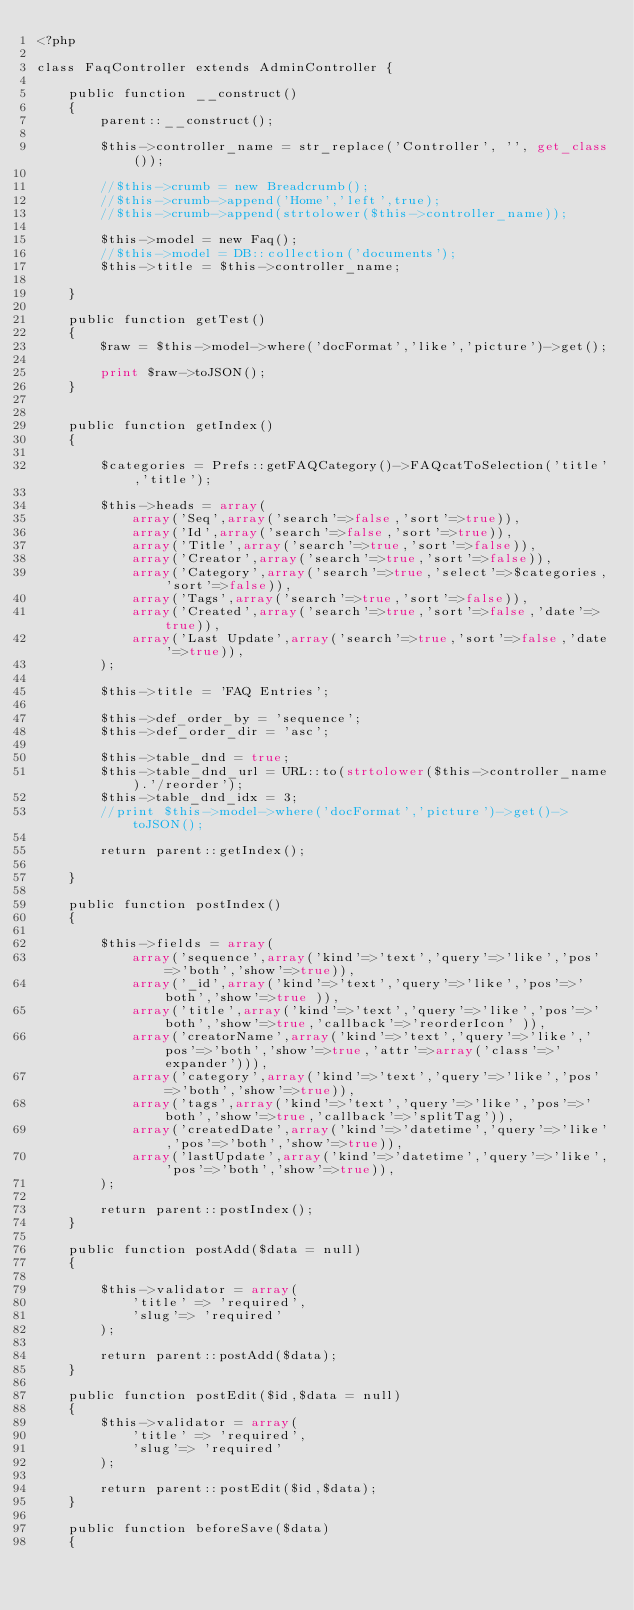Convert code to text. <code><loc_0><loc_0><loc_500><loc_500><_PHP_><?php

class FaqController extends AdminController {

    public function __construct()
    {
        parent::__construct();

        $this->controller_name = str_replace('Controller', '', get_class());

        //$this->crumb = new Breadcrumb();
        //$this->crumb->append('Home','left',true);
        //$this->crumb->append(strtolower($this->controller_name));

        $this->model = new Faq();
        //$this->model = DB::collection('documents');
        $this->title = $this->controller_name;

    }

    public function getTest()
    {
        $raw = $this->model->where('docFormat','like','picture')->get();

        print $raw->toJSON();
    }


    public function getIndex()
    {

        $categories = Prefs::getFAQCategory()->FAQcatToSelection('title','title');

        $this->heads = array(
            array('Seq',array('search'=>false,'sort'=>true)),
            array('Id',array('search'=>false,'sort'=>true)),
            array('Title',array('search'=>true,'sort'=>false)),
            array('Creator',array('search'=>true,'sort'=>false)),
            array('Category',array('search'=>true,'select'=>$categories,'sort'=>false)),
            array('Tags',array('search'=>true,'sort'=>false)),
            array('Created',array('search'=>true,'sort'=>false,'date'=>true)),
            array('Last Update',array('search'=>true,'sort'=>false,'date'=>true)),
        );

        $this->title = 'FAQ Entries';

        $this->def_order_by = 'sequence';
        $this->def_order_dir = 'asc';

        $this->table_dnd = true;
        $this->table_dnd_url = URL::to(strtolower($this->controller_name).'/reorder');
        $this->table_dnd_idx = 3;
        //print $this->model->where('docFormat','picture')->get()->toJSON();

        return parent::getIndex();

    }

    public function postIndex()
    {

        $this->fields = array(
            array('sequence',array('kind'=>'text','query'=>'like','pos'=>'both','show'=>true)),
            array('_id',array('kind'=>'text','query'=>'like','pos'=>'both','show'=>true )),
            array('title',array('kind'=>'text','query'=>'like','pos'=>'both','show'=>true,'callback'=>'reorderIcon' )),
            array('creatorName',array('kind'=>'text','query'=>'like','pos'=>'both','show'=>true,'attr'=>array('class'=>'expander'))),
            array('category',array('kind'=>'text','query'=>'like','pos'=>'both','show'=>true)),
            array('tags',array('kind'=>'text','query'=>'like','pos'=>'both','show'=>true,'callback'=>'splitTag')),
            array('createdDate',array('kind'=>'datetime','query'=>'like','pos'=>'both','show'=>true)),
            array('lastUpdate',array('kind'=>'datetime','query'=>'like','pos'=>'both','show'=>true)),
        );

        return parent::postIndex();
    }

    public function postAdd($data = null)
    {

        $this->validator = array(
            'title' => 'required',
            'slug'=> 'required'
        );

        return parent::postAdd($data);
    }

    public function postEdit($id,$data = null)
    {
        $this->validator = array(
            'title' => 'required',
            'slug'=> 'required'
        );

        return parent::postEdit($id,$data);
    }

    public function beforeSave($data)
    {</code> 